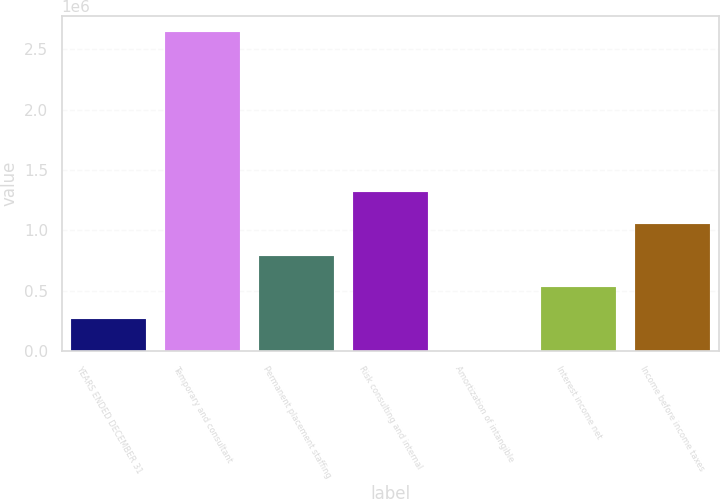Convert chart. <chart><loc_0><loc_0><loc_500><loc_500><bar_chart><fcel>YEARS ENDED DECEMBER 31<fcel>Temporary and consultant<fcel>Permanent placement staffing<fcel>Risk consulting and internal<fcel>Amortization of intangible<fcel>Interest income net<fcel>Income before income taxes<nl><fcel>264323<fcel>2.64021e+06<fcel>792298<fcel>1.32027e+06<fcel>335<fcel>528310<fcel>1.05629e+06<nl></chart> 